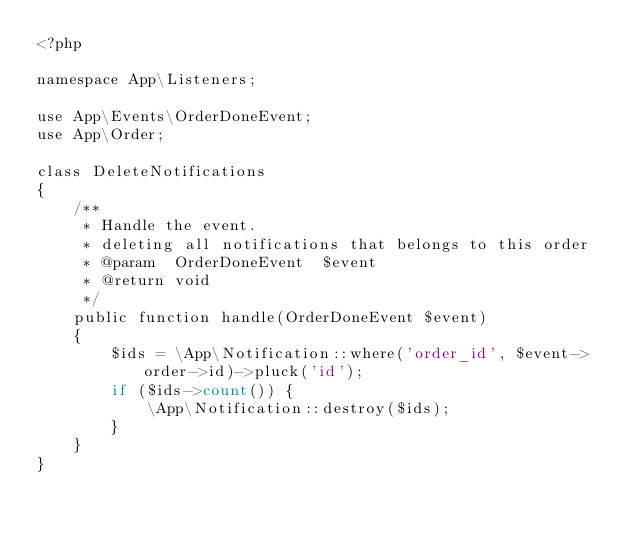<code> <loc_0><loc_0><loc_500><loc_500><_PHP_><?php

namespace App\Listeners;

use App\Events\OrderDoneEvent;
use App\Order;

class DeleteNotifications
{
    /**
     * Handle the event.
     * deleting all notifications that belongs to this order
     * @param  OrderDoneEvent  $event
     * @return void
     */
    public function handle(OrderDoneEvent $event)
    {
        $ids = \App\Notification::where('order_id', $event->order->id)->pluck('id');
        if ($ids->count()) {
            \App\Notification::destroy($ids);
        }
    }
}
</code> 